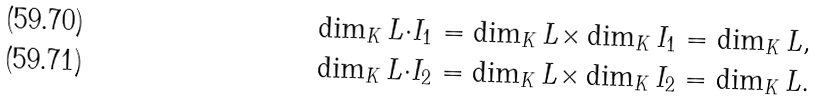<formula> <loc_0><loc_0><loc_500><loc_500>\dim _ { K } L { \cdot } I _ { 1 } & = \dim _ { K } L { \times } \dim _ { K } I _ { 1 } = \dim _ { K } L , \\ \dim _ { K } L { \cdot } I _ { 2 } & = \dim _ { K } L { \times } \dim _ { K } I _ { 2 } = \dim _ { K } L .</formula> 